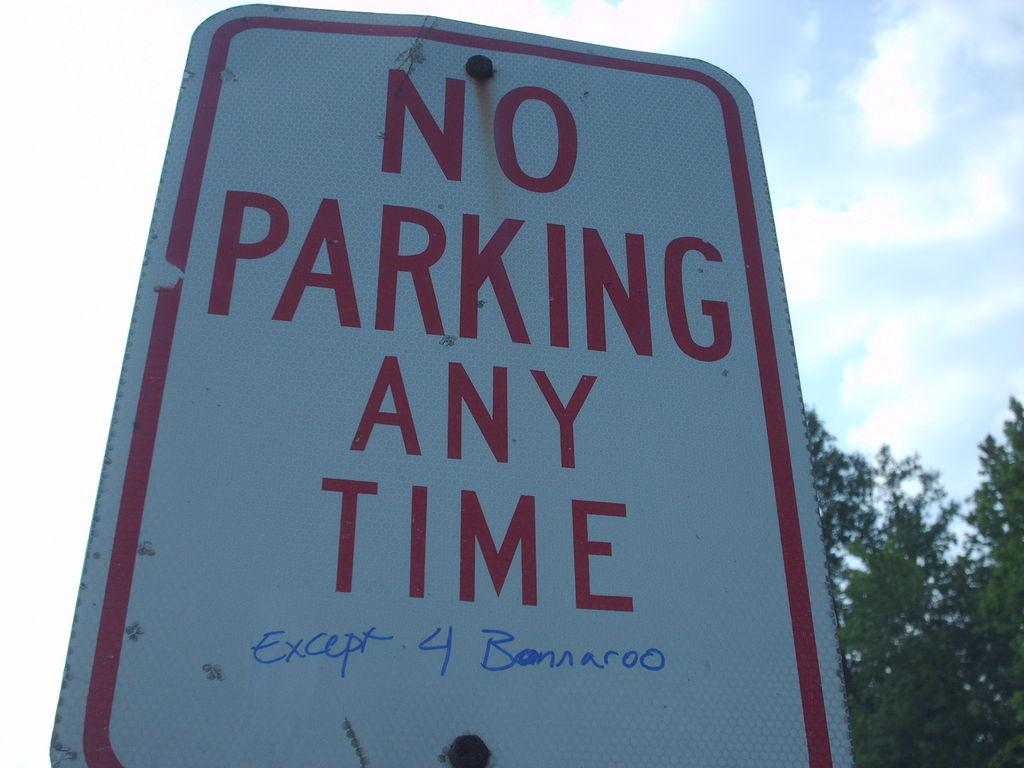<image>
Render a clear and concise summary of the photo. A street sign designates no parking any time. 